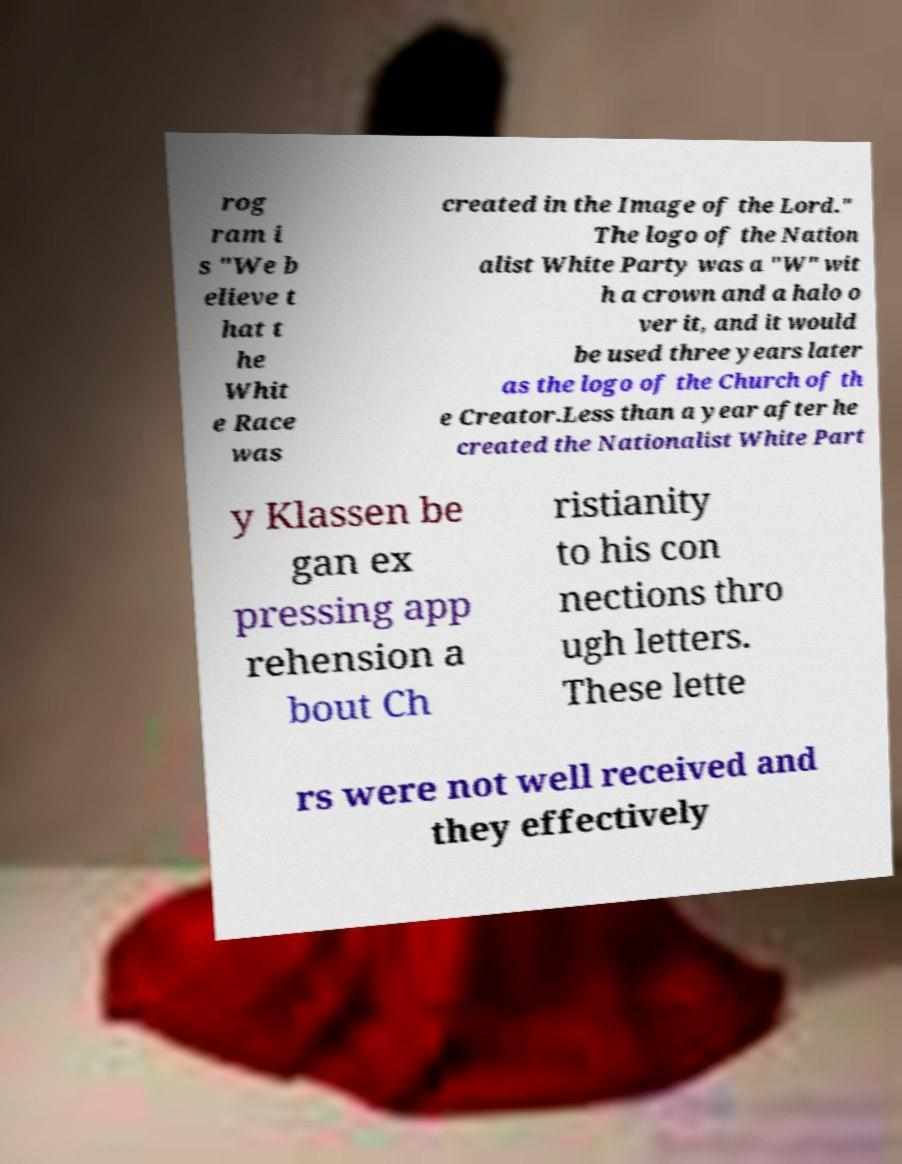What messages or text are displayed in this image? I need them in a readable, typed format. rog ram i s "We b elieve t hat t he Whit e Race was created in the Image of the Lord." The logo of the Nation alist White Party was a "W" wit h a crown and a halo o ver it, and it would be used three years later as the logo of the Church of th e Creator.Less than a year after he created the Nationalist White Part y Klassen be gan ex pressing app rehension a bout Ch ristianity to his con nections thro ugh letters. These lette rs were not well received and they effectively 